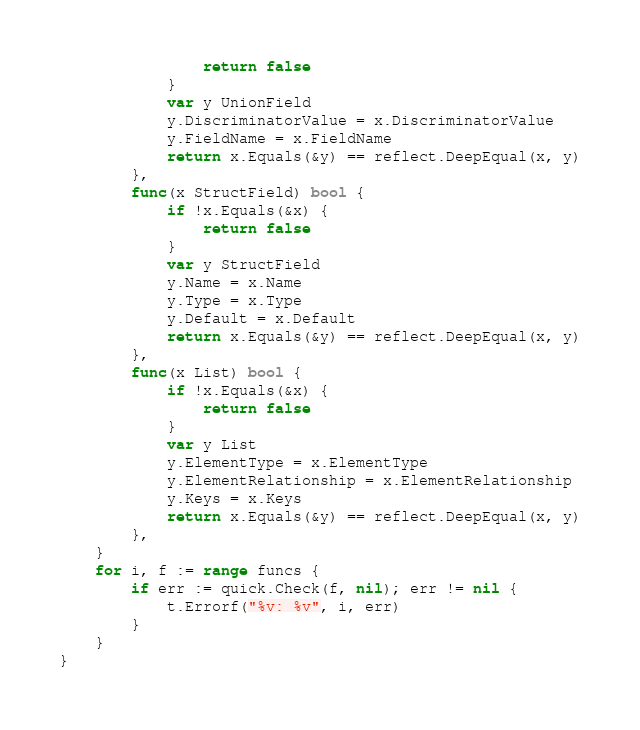Convert code to text. <code><loc_0><loc_0><loc_500><loc_500><_Go_>				return false
			}
			var y UnionField
			y.DiscriminatorValue = x.DiscriminatorValue
			y.FieldName = x.FieldName
			return x.Equals(&y) == reflect.DeepEqual(x, y)
		},
		func(x StructField) bool {
			if !x.Equals(&x) {
				return false
			}
			var y StructField
			y.Name = x.Name
			y.Type = x.Type
			y.Default = x.Default
			return x.Equals(&y) == reflect.DeepEqual(x, y)
		},
		func(x List) bool {
			if !x.Equals(&x) {
				return false
			}
			var y List
			y.ElementType = x.ElementType
			y.ElementRelationship = x.ElementRelationship
			y.Keys = x.Keys
			return x.Equals(&y) == reflect.DeepEqual(x, y)
		},
	}
	for i, f := range funcs {
		if err := quick.Check(f, nil); err != nil {
			t.Errorf("%v: %v", i, err)
		}
	}
}
</code> 